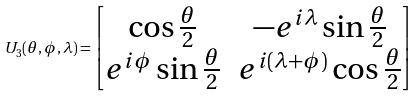<formula> <loc_0><loc_0><loc_500><loc_500>U _ { 3 } ( \theta , \phi , \lambda ) = \begin{bmatrix} \cos \frac { \theta } { 2 } & - e ^ { i \lambda } \sin \frac { \theta } { 2 } \\ e ^ { i \phi } \sin \frac { \theta } { 2 } & e ^ { i ( \lambda + \phi ) } \cos \frac { \theta } { 2 } \end{bmatrix}</formula> 